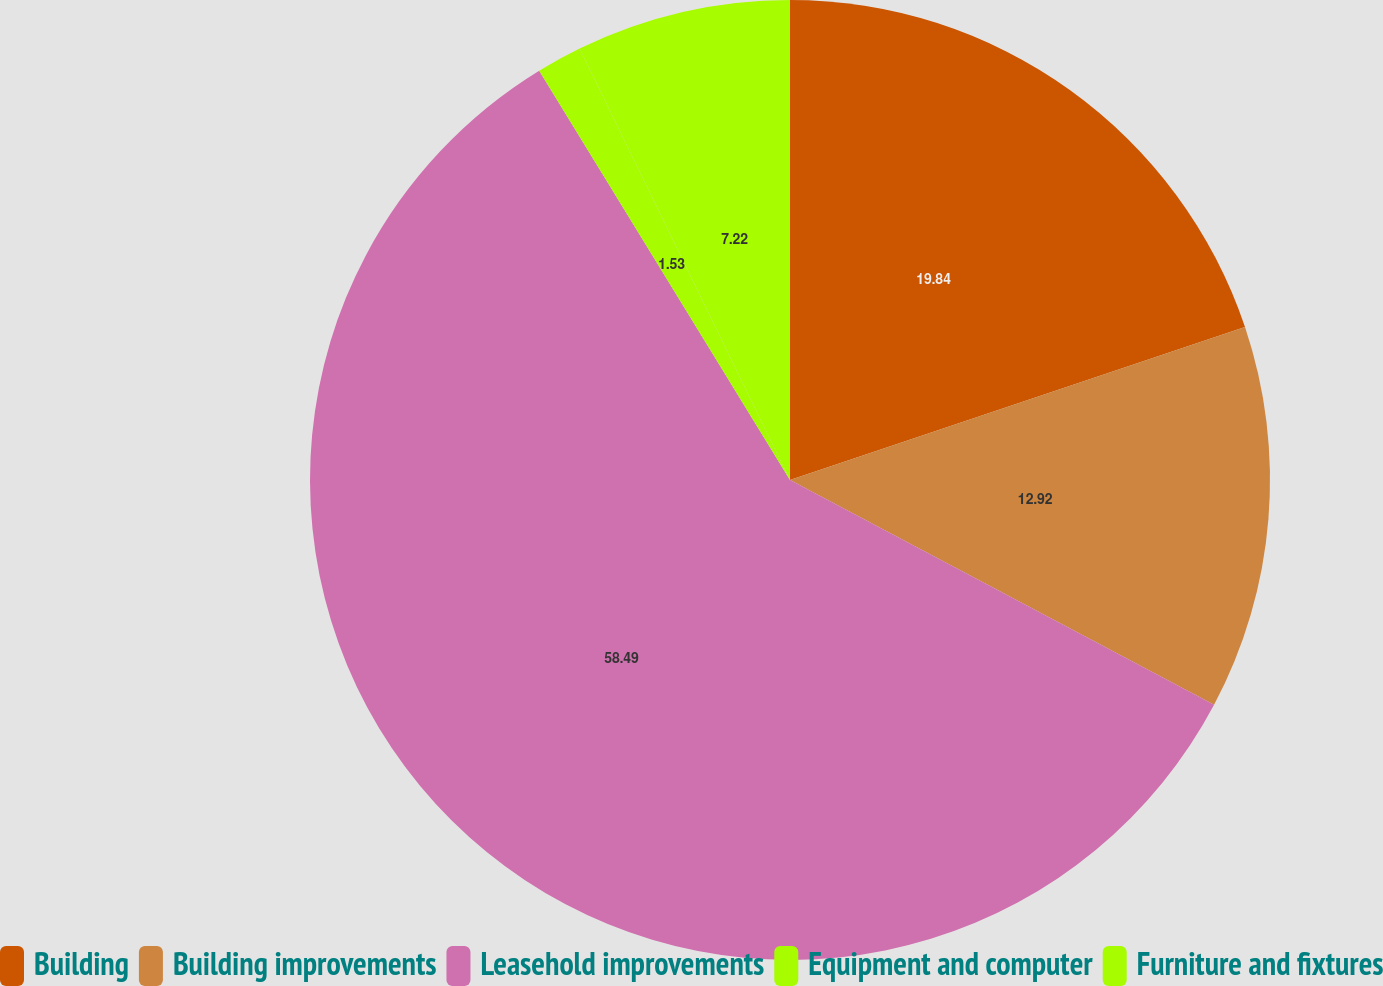<chart> <loc_0><loc_0><loc_500><loc_500><pie_chart><fcel>Building<fcel>Building improvements<fcel>Leasehold improvements<fcel>Equipment and computer<fcel>Furniture and fixtures<nl><fcel>19.84%<fcel>12.92%<fcel>58.49%<fcel>1.53%<fcel>7.22%<nl></chart> 